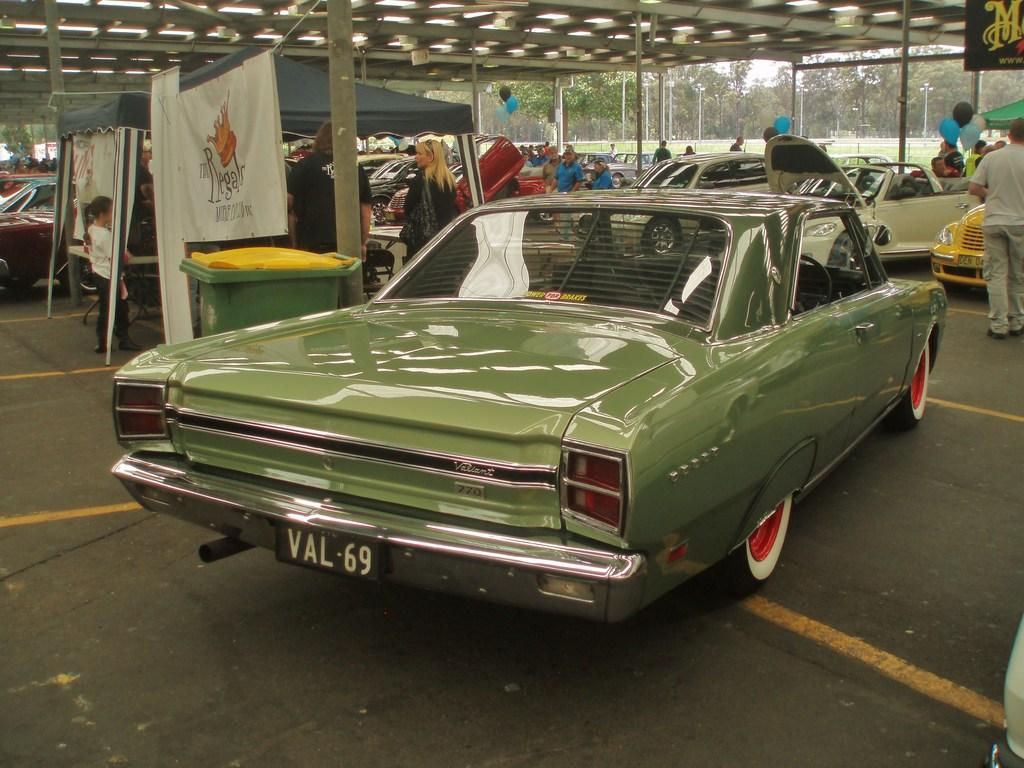What type of vehicles can be seen in the image? There are cars in the image. Who or what else is present in the image? There are people and tents in the image. What object is used for disposing of waste in the image? There is a dustbin in the image. What type of signage is visible in the image? There are banners in the image. What is the ceiling made of in the image? The top of the image features a ceiling, but the material is not specified. What type of vegetation can be seen in the background of the image? There are trees in the background of the image. What architectural feature is present in the background of the image? There is fencing in the background of the image. What type of mitten is being used by the people in the image? There is no mention of mittens in the image; people are not wearing any. How many bodies are visible in the image? The term "body" is not relevant to the image, as it features people and objects, not human remains. 